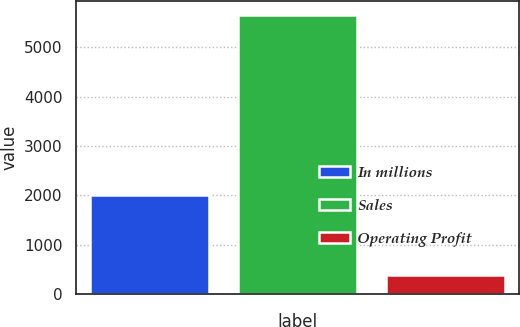Convert chart. <chart><loc_0><loc_0><loc_500><loc_500><bar_chart><fcel>In millions<fcel>Sales<fcel>Operating Profit<nl><fcel>2013<fcel>5650<fcel>389<nl></chart> 